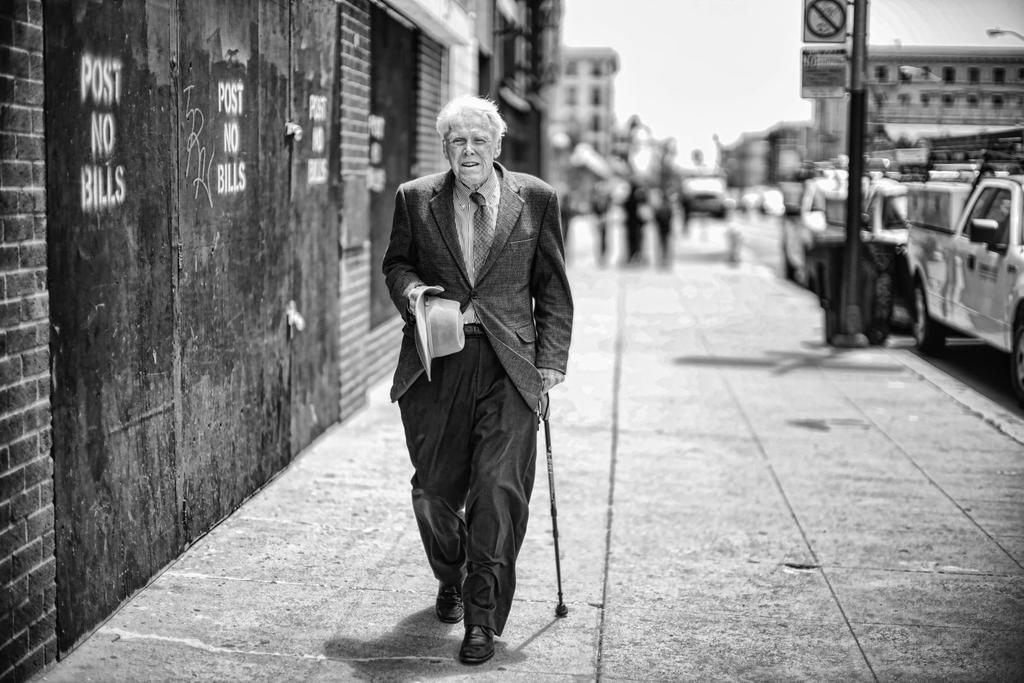What is the color scheme of the image? The image is black and white. Who is present in the image? There is a man in the image. What is the man holding in the image? The man is holding a hat and a stick. What can be seen in the background of the image? The background is blurred, but there are signboards, vehicles, people, and buildings visible. Can you see a yak walking on a trail in the image? No, there is no yak or trail present in the image. 